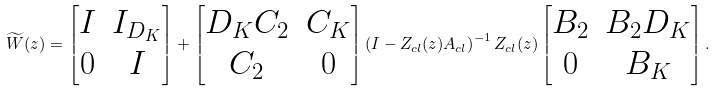<formula> <loc_0><loc_0><loc_500><loc_500>\widetilde { W } ( z ) = \begin{bmatrix} I & I _ { D _ { K } } \\ 0 & I \end{bmatrix} + \begin{bmatrix} D _ { K } C _ { 2 } & C _ { K } \\ C _ { 2 } & 0 \end{bmatrix} \left ( I - Z _ { c l } ( z ) A _ { c l } \right ) ^ { - 1 } Z _ { c l } ( z ) \begin{bmatrix} B _ { 2 } & B _ { 2 } D _ { K } \\ 0 & B _ { K } \end{bmatrix} .</formula> 